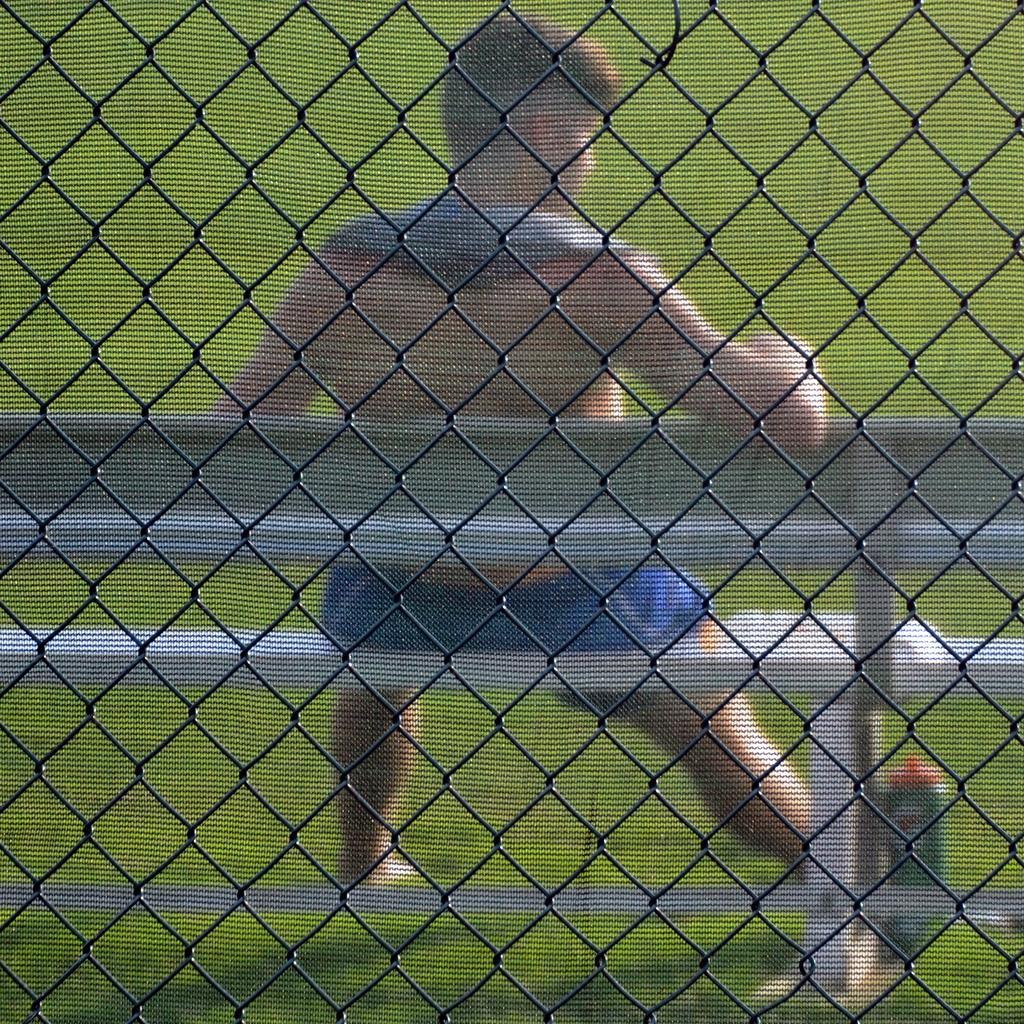How would you summarize this image in a sentence or two? In this image, there is a fence, at the background there is a man sitting on a bench, there is green color grass on the ground. 